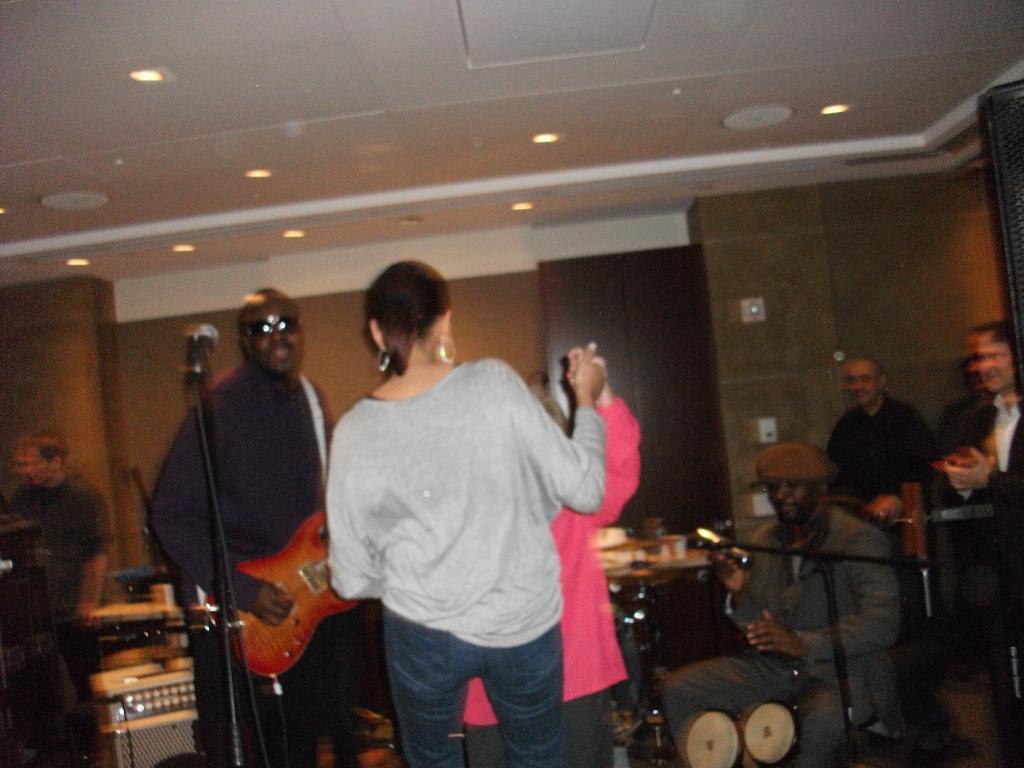In one or two sentences, can you explain what this image depicts? In the image we can see few persons were standing and few persons were sitting. In front we can see microphone and center man holding guitar. And back we can see wall and few musical instruments. 